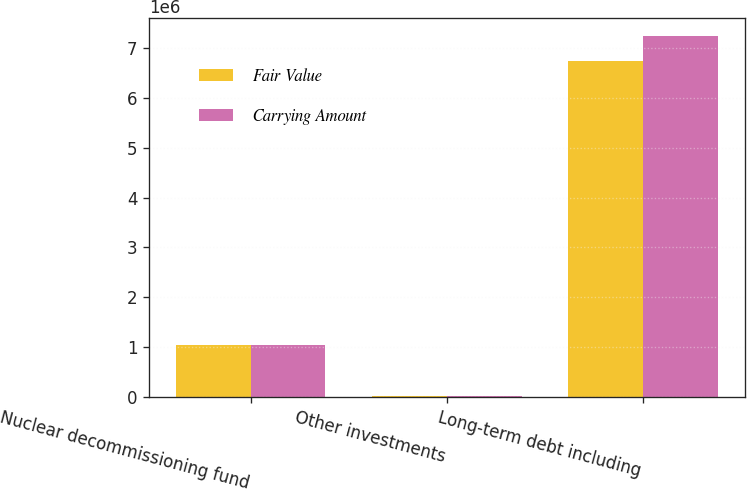Convert chart to OTSL. <chart><loc_0><loc_0><loc_500><loc_500><stacked_bar_chart><ecel><fcel>Nuclear decommissioning fund<fcel>Other investments<fcel>Long-term debt including<nl><fcel>Fair Value<fcel>1.04759e+06<fcel>24286<fcel>6.73328e+06<nl><fcel>Carrying Amount<fcel>1.04759e+06<fcel>24050<fcel>7.24535e+06<nl></chart> 